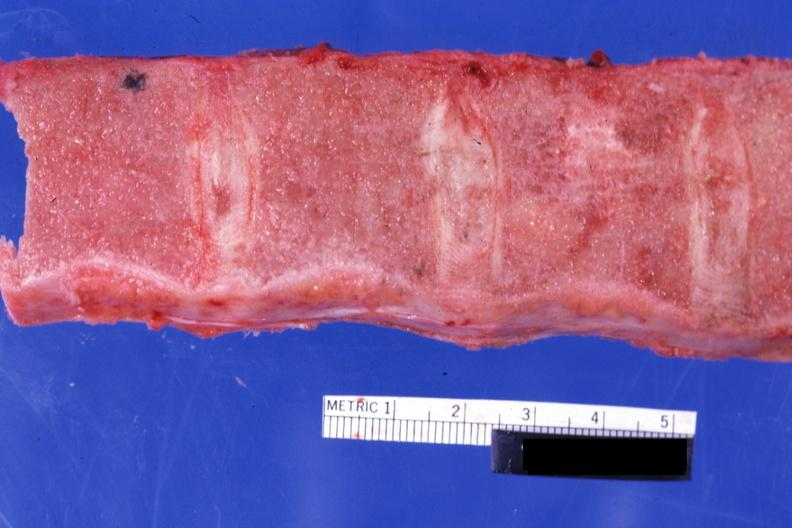what does this image show?
Answer the question using a single word or phrase. Sectioned vertebrae with no red marrow case of chronic myelogenous leukemia in blast crisis 